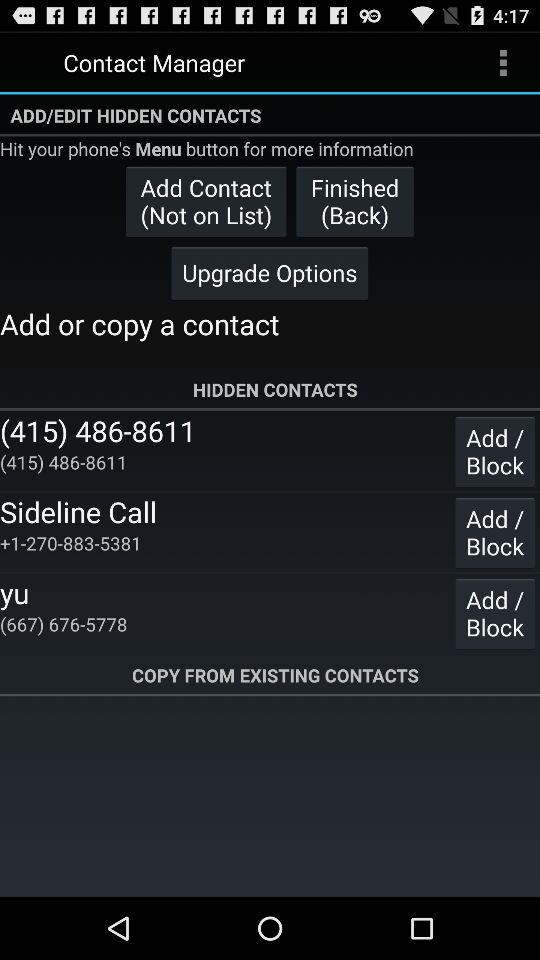What is the number of Yu? The number of Yu is (667) 676-5778. 